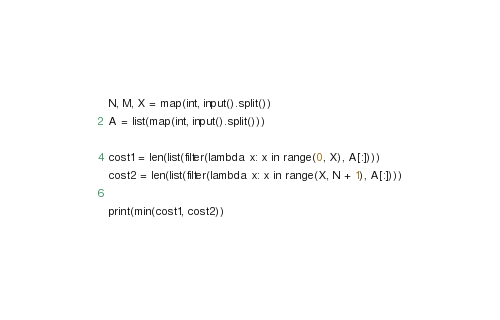Convert code to text. <code><loc_0><loc_0><loc_500><loc_500><_Python_>N, M, X = map(int, input().split())
A = list(map(int, input().split()))

cost1 = len(list(filter(lambda x: x in range(0, X), A[:])))
cost2 = len(list(filter(lambda x: x in range(X, N + 1), A[:])))

print(min(cost1, cost2))</code> 